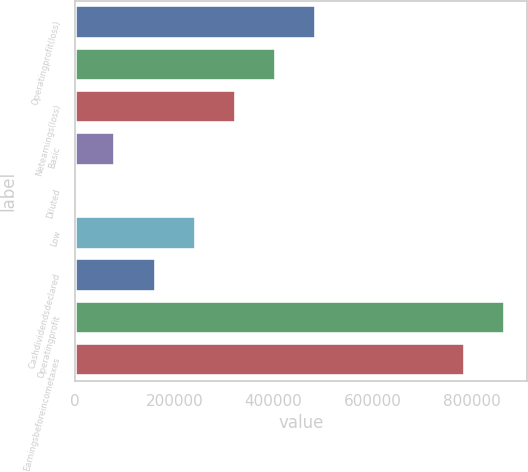<chart> <loc_0><loc_0><loc_500><loc_500><bar_chart><fcel>Operatingprofit(loss)<fcel>Unnamed: 1<fcel>Netearnings(loss)<fcel>Basic<fcel>Diluted<fcel>Low<fcel>Cashdividendsdeclared<fcel>Operatingprofit<fcel>Earningsbeforeincometaxes<nl><fcel>486216<fcel>405180<fcel>324145<fcel>81037.5<fcel>1.74<fcel>243109<fcel>162073<fcel>867186<fcel>786150<nl></chart> 